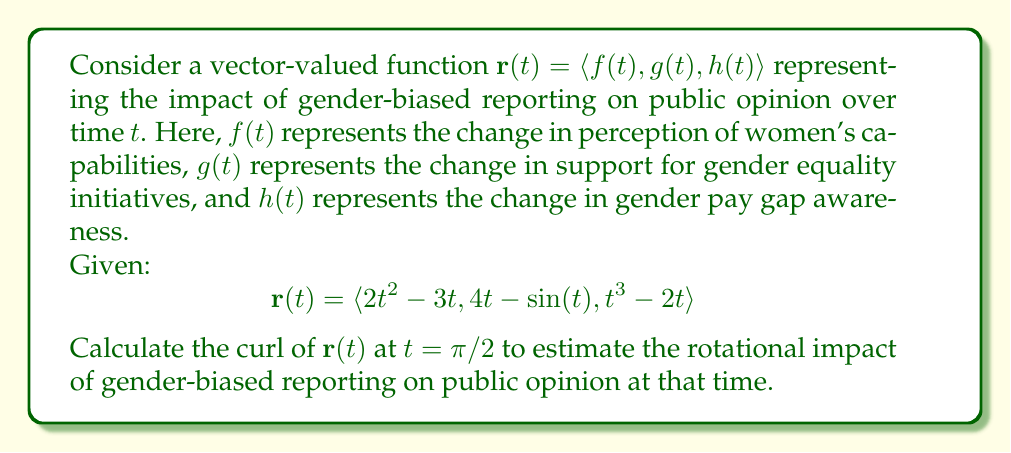Solve this math problem. To solve this problem, we need to follow these steps:

1) First, recall that the curl of a vector field $\mathbf{F}(x, y, z) = \langle P, Q, R \rangle$ is defined as:

   $$\text{curl }\mathbf{F} = \nabla \times \mathbf{F} = \left\langle \frac{\partial R}{\partial y} - \frac{\partial Q}{\partial z}, \frac{\partial P}{\partial z} - \frac{\partial R}{\partial x}, \frac{\partial Q}{\partial x} - \frac{\partial P}{\partial y} \right\rangle$$

2) In our case, we have a vector-valued function of a single parameter $t$. We can think of this as a space curve where $x = f(t)$, $y = g(t)$, and $z = h(t)$. To find the curl, we need to use the chain rule:

   $$\text{curl }\mathbf{r} = \left\langle \frac{dh}{dy} - \frac{dg}{dz}, \frac{df}{dz} - \frac{dh}{dx}, \frac{dg}{dx} - \frac{df}{dy} \right\rangle$$

3) Let's calculate each component:

   $\frac{dh}{dy} = \frac{dh/dt}{dg/dt} = \frac{3t^2 - 2}{4 - \cos(t)}$

   $\frac{dg}{dz} = \frac{dg/dt}{dh/dt} = \frac{4 - \cos(t)}{3t^2 - 2}$

   $\frac{df}{dz} = \frac{df/dt}{dh/dt} = \frac{4t - 3}{3t^2 - 2}$

   $\frac{dh}{dx} = \frac{dh/dt}{df/dt} = \frac{3t^2 - 2}{4t - 3}$

   $\frac{dg}{dx} = \frac{dg/dt}{df/dt} = \frac{4 - \cos(t)}{4t - 3}$

   $\frac{df}{dy} = \frac{df/dt}{dg/dt} = \frac{4t - 3}{4 - \cos(t)}$

4) Now we can form the curl:

   $$\text{curl }\mathbf{r} = \left\langle \frac{3t^2 - 2}{4 - \cos(t)} - \frac{4 - \cos(t)}{3t^2 - 2}, \frac{4t - 3}{3t^2 - 2} - \frac{3t^2 - 2}{4t - 3}, \frac{4 - \cos(t)}{4t - 3} - \frac{4t - 3}{4 - \cos(t)} \right\rangle$$

5) We need to evaluate this at $t = \pi/2$. Let's substitute:

   $$\text{curl }\mathbf{r}(\pi/2) = \left\langle \frac{3(\pi/2)^2 - 2}{4 - \cos(\pi/2)} - \frac{4 - \cos(\pi/2)}{3(\pi/2)^2 - 2}, \frac{4(\pi/2) - 3}{3(\pi/2)^2 - 2} - \frac{3(\pi/2)^2 - 2}{4(\pi/2) - 3}, \frac{4 - \cos(\pi/2)}{4(\pi/2) - 3} - \frac{4(\pi/2) - 3}{4 - \cos(\pi/2)} \right\rangle$$

6) Simplify:

   $$\text{curl }\mathbf{r}(\pi/2) = \left\langle \frac{3\pi^2/4 - 2}{4 - 0} - \frac{4 - 0}{3\pi^2/4 - 2}, \frac{2\pi - 3}{3\pi^2/4 - 2} - \frac{3\pi^2/4 - 2}{2\pi - 3}, \frac{4 - 0}{2\pi - 3} - \frac{2\pi - 3}{4 - 0} \right\rangle$$

This is the curl of $\mathbf{r}(t)$ at $t = \pi/2$, representing the rotational impact of gender-biased reporting on public opinion at that time.
Answer: $$\text{curl }\mathbf{r}(\pi/2) = \left\langle \frac{3\pi^2/4 - 2}{4} - \frac{4}{3\pi^2/4 - 2}, \frac{2\pi - 3}{3\pi^2/4 - 2} - \frac{3\pi^2/4 - 2}{2\pi - 3}, 1 - \frac{2\pi - 3}{4} \right\rangle$$ 